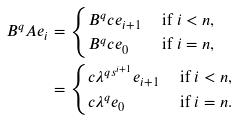<formula> <loc_0><loc_0><loc_500><loc_500>B ^ { q } A e _ { i } & = \begin{cases} B ^ { q } c e _ { i + 1 } & \text { if } i < n , \\ B ^ { q } c e _ { 0 } & \text { if } i = n , \end{cases} \\ & = \begin{cases} c \lambda ^ { q s ^ { i + 1 } } e _ { i + 1 } & \text { if } i < n , \\ c \lambda ^ { q } e _ { 0 } & \text { if } i = n . \end{cases}</formula> 